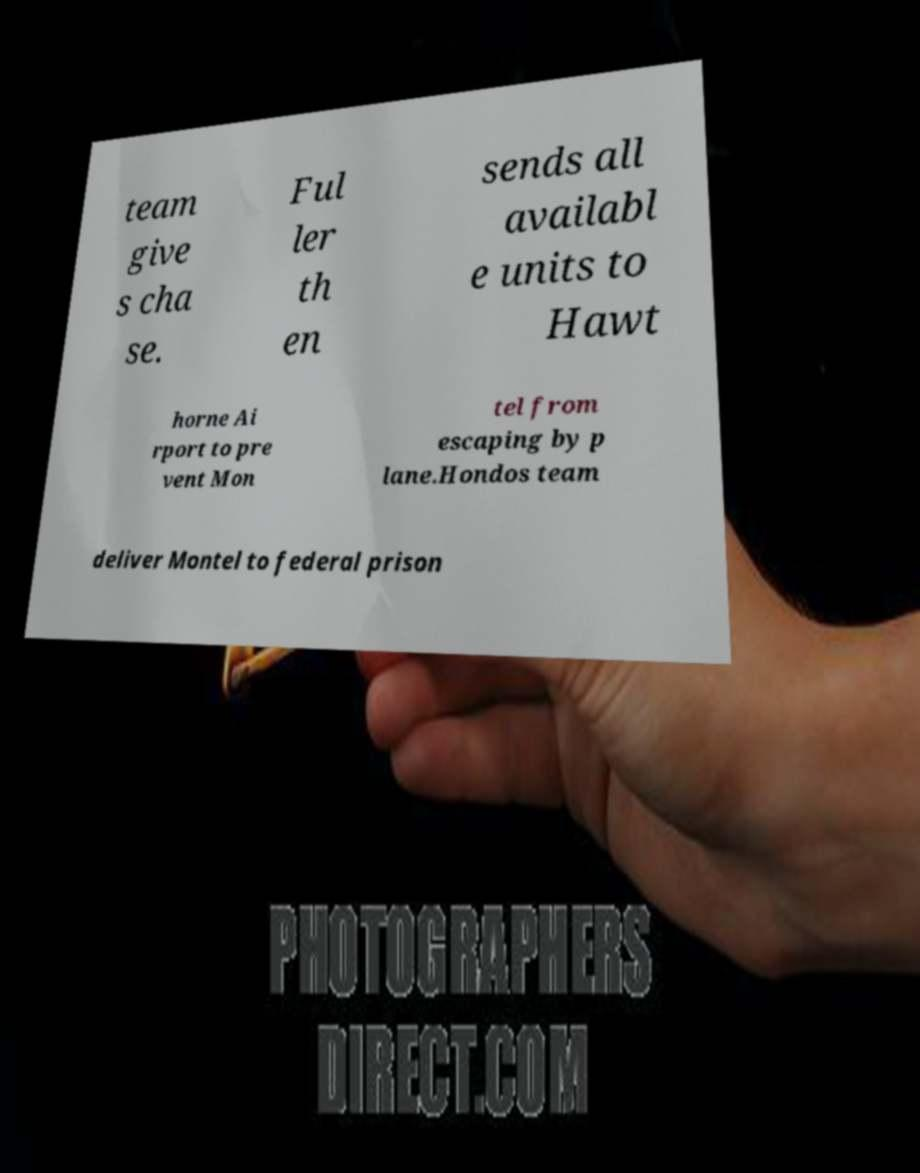Can you accurately transcribe the text from the provided image for me? team give s cha se. Ful ler th en sends all availabl e units to Hawt horne Ai rport to pre vent Mon tel from escaping by p lane.Hondos team deliver Montel to federal prison 